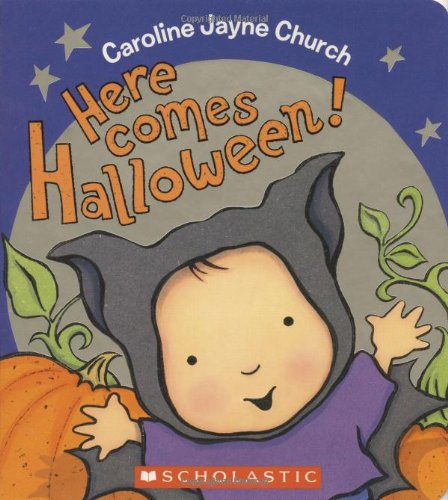What is the genre of this book? This book falls under the genre of Children's Books, specifically tailored to young readers with engaging stories and colorful, child-friendly illustrations. 